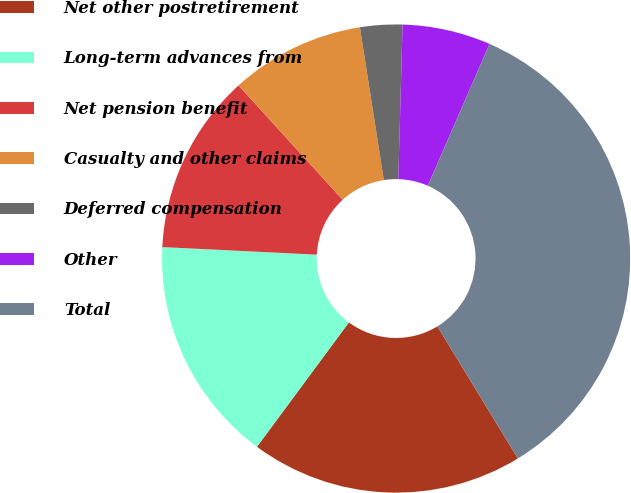Convert chart. <chart><loc_0><loc_0><loc_500><loc_500><pie_chart><fcel>Net other postretirement<fcel>Long-term advances from<fcel>Net pension benefit<fcel>Casualty and other claims<fcel>Deferred compensation<fcel>Other<fcel>Total<nl><fcel>18.84%<fcel>15.65%<fcel>12.47%<fcel>9.28%<fcel>2.91%<fcel>6.1%<fcel>34.76%<nl></chart> 